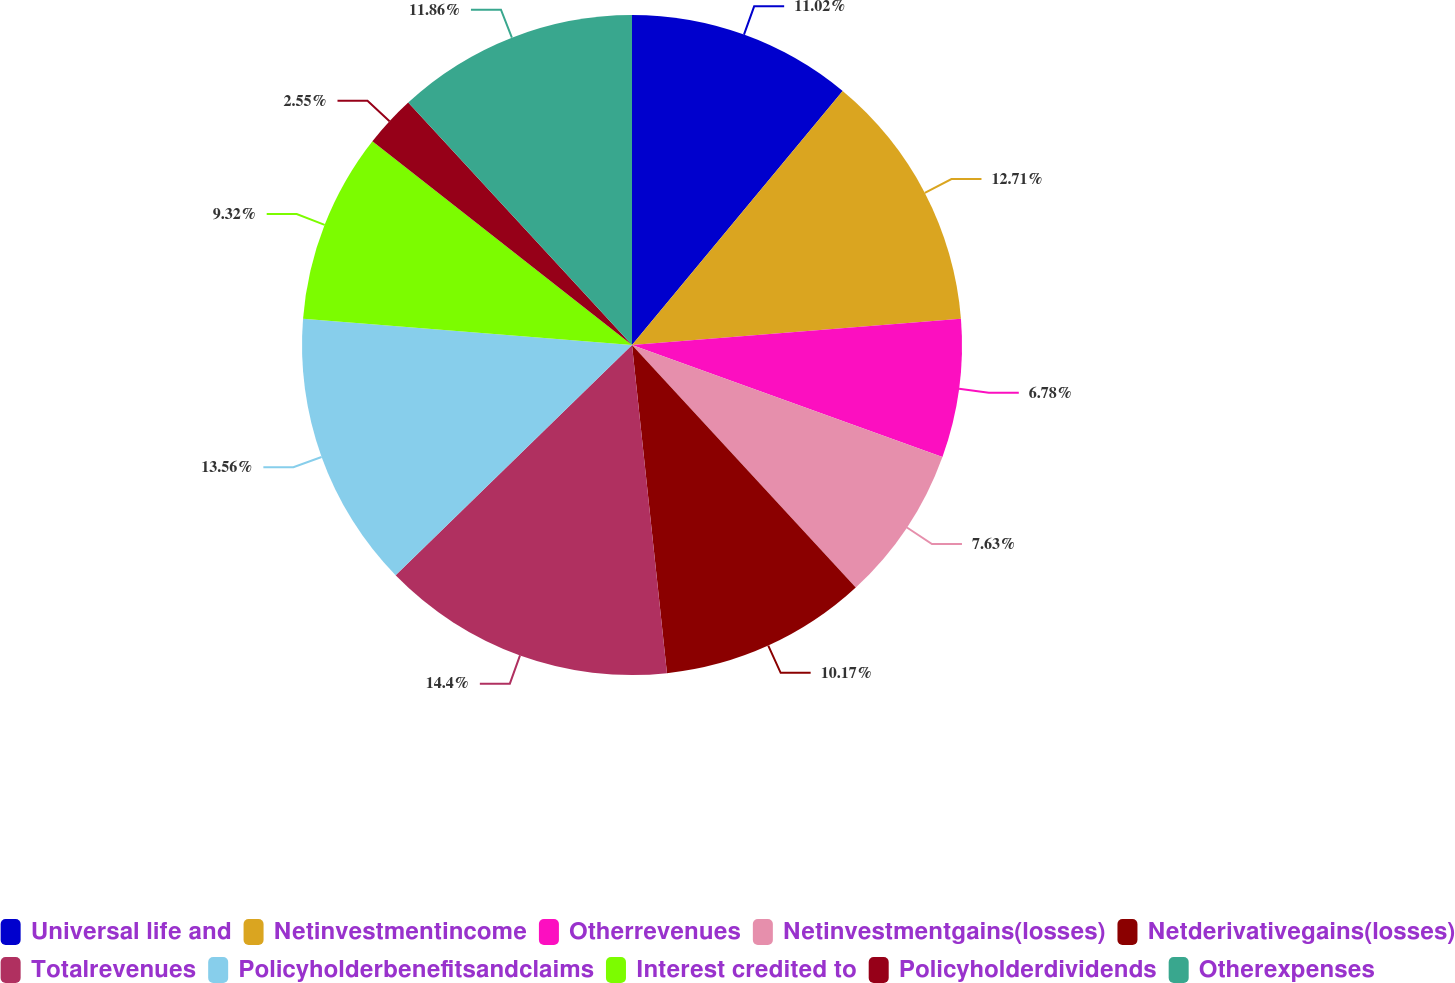Convert chart. <chart><loc_0><loc_0><loc_500><loc_500><pie_chart><fcel>Universal life and<fcel>Netinvestmentincome<fcel>Otherrevenues<fcel>Netinvestmentgains(losses)<fcel>Netderivativegains(losses)<fcel>Totalrevenues<fcel>Policyholderbenefitsandclaims<fcel>Interest credited to<fcel>Policyholderdividends<fcel>Otherexpenses<nl><fcel>11.02%<fcel>12.71%<fcel>6.78%<fcel>7.63%<fcel>10.17%<fcel>14.4%<fcel>13.56%<fcel>9.32%<fcel>2.55%<fcel>11.86%<nl></chart> 